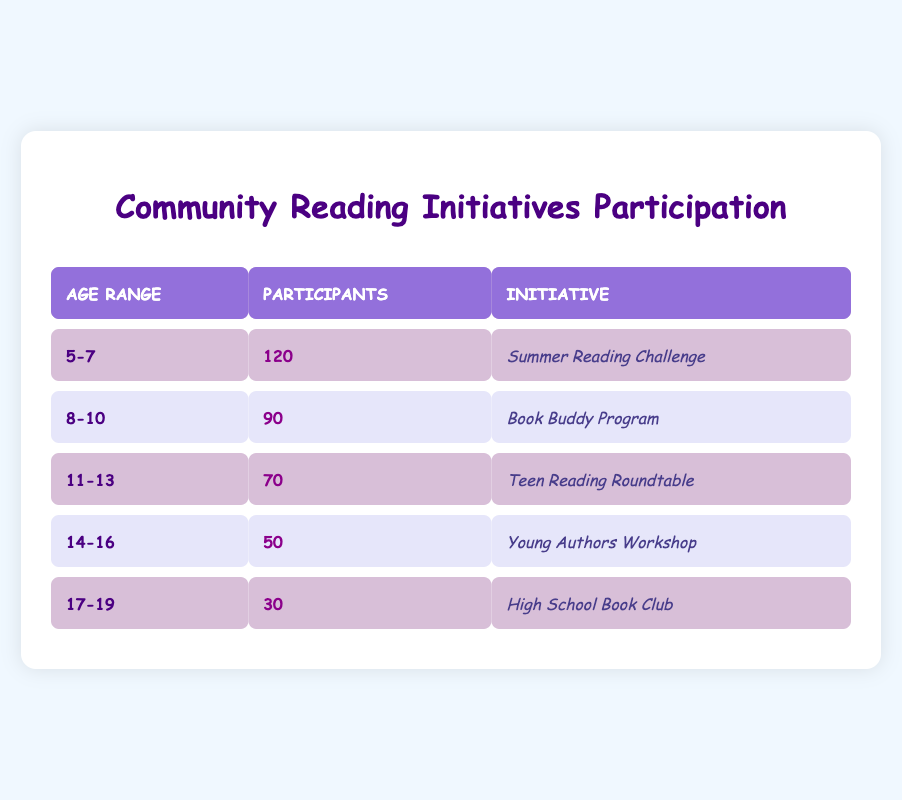What is the total number of participants in the community-led reading initiatives? To find the total number of participants, we need to sum the participants across all age groups: 120 (5-7) + 90 (8-10) + 70 (11-13) + 50 (14-16) + 30 (17-19) = 360.
Answer: 360 Which reading initiative had the least number of participants? By examining the participants for each initiative, 30 participants are associated with the "High School Book Club," which is the lowest compared to others (50 for Young Authors Workshop, 70 for Teen Reading Roundtable, etc.).
Answer: High School Book Club Is the number of participants in the "Summer Reading Challenge" greater than the combined participants in "Teen Reading Roundtable" and "Young Authors Workshop"? "Summer Reading Challenge" has 120 participants. For "Teen Reading Roundtable," there are 70, and for "Young Authors Workshop," there are 50, giving a combined total of 70 + 50 = 120. Since 120 equals the combined total, the answer is no.
Answer: No What is the age group with the highest participation, and how many participants are there? The age group with the highest participation is 5-7 years old, with 120 participants as indicated in the table, where those numbers are listed.
Answer: 5-7 years old, 120 participants What percentage of total participants are from the "Book Buddy Program"? We know the total participants are 360. The participants in the "Book Buddy Program" from the 8-10 age group are 90. To find the percentage, we calculate (90 / 360) * 100 = 25%.
Answer: 25% How many more participants are in the "Summer Reading Challenge" than in the "High School Book Club"? The "Summer Reading Challenge" has 120 participants and the "High School Book Club" has 30 participants. The difference is 120 - 30 = 90.
Answer: 90 Is it true that all age groups have more than 40 participants? Checking the participants: Each age group (5-7, 8-10, 11-13, 14-16, 17-19) has 120, 90, 70, 50, and 30 participants, respectively. The age group 17-19 has only 30 participants, which is less than 40.
Answer: No What is the median number of participants across the age groups? To find the median, we need to arrange the number of participants (30, 50, 70, 90, 120) in numerical order. There are five data points, so the median is the third value in this ordered list, which is 70.
Answer: 70 